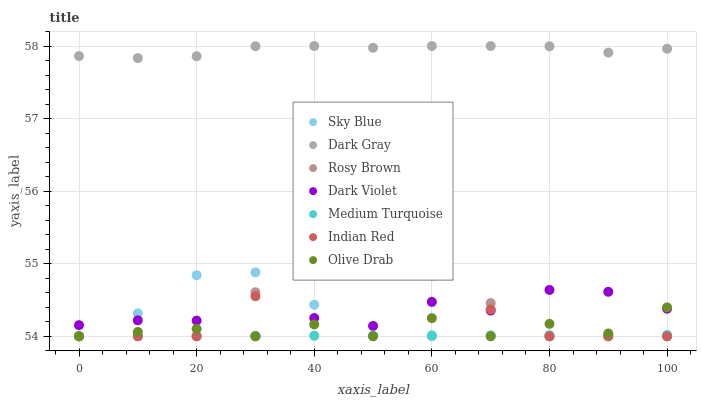Does Medium Turquoise have the minimum area under the curve?
Answer yes or no. Yes. Does Dark Gray have the maximum area under the curve?
Answer yes or no. Yes. Does Rosy Brown have the minimum area under the curve?
Answer yes or no. No. Does Rosy Brown have the maximum area under the curve?
Answer yes or no. No. Is Medium Turquoise the smoothest?
Answer yes or no. Yes. Is Dark Violet the roughest?
Answer yes or no. Yes. Is Rosy Brown the smoothest?
Answer yes or no. No. Is Rosy Brown the roughest?
Answer yes or no. No. Does Medium Turquoise have the lowest value?
Answer yes or no. Yes. Does Dark Gray have the lowest value?
Answer yes or no. No. Does Dark Gray have the highest value?
Answer yes or no. Yes. Does Rosy Brown have the highest value?
Answer yes or no. No. Is Dark Violet less than Dark Gray?
Answer yes or no. Yes. Is Dark Gray greater than Sky Blue?
Answer yes or no. Yes. Does Olive Drab intersect Medium Turquoise?
Answer yes or no. Yes. Is Olive Drab less than Medium Turquoise?
Answer yes or no. No. Is Olive Drab greater than Medium Turquoise?
Answer yes or no. No. Does Dark Violet intersect Dark Gray?
Answer yes or no. No. 